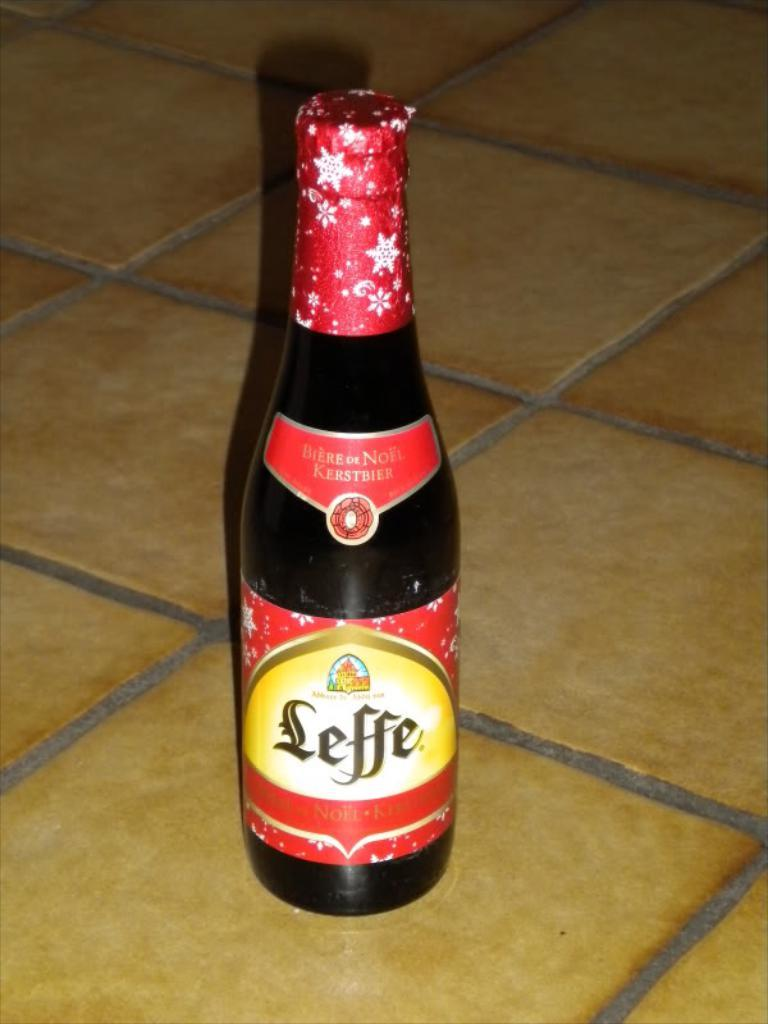Provide a one-sentence caption for the provided image. The Leffe beer bottle has red foil around the top with white snowflakes on it. 